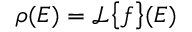<formula> <loc_0><loc_0><loc_500><loc_500>\rho ( E ) = \mathcal { L } \left \{ f \right \} ( E )</formula> 